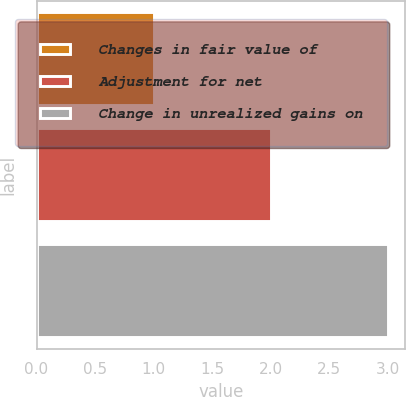Convert chart to OTSL. <chart><loc_0><loc_0><loc_500><loc_500><bar_chart><fcel>Changes in fair value of<fcel>Adjustment for net<fcel>Change in unrealized gains on<nl><fcel>1<fcel>2<fcel>3<nl></chart> 